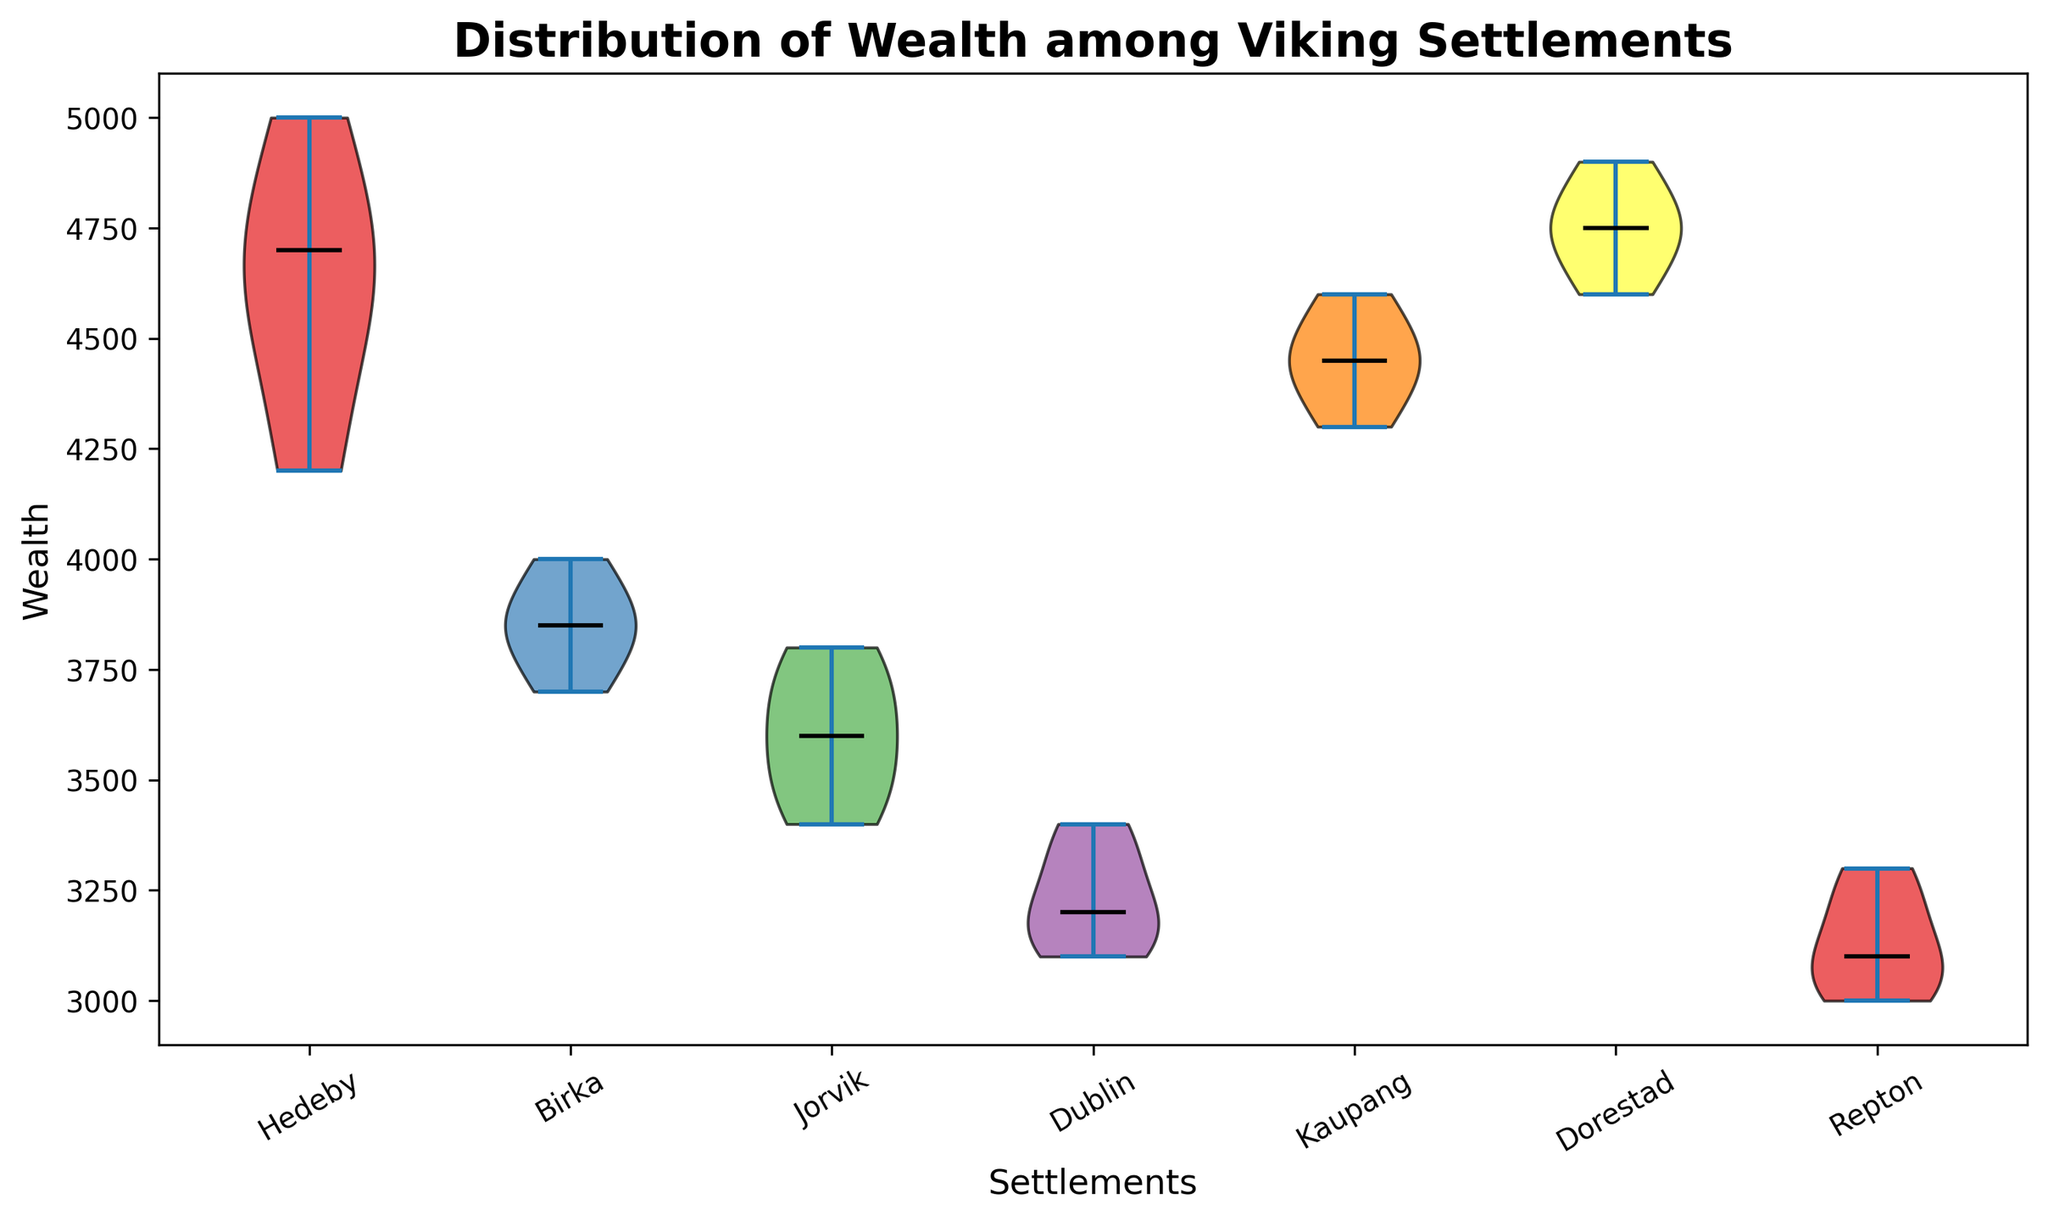What is the median wealth in Hedeby? Since it is a violin plot with medians indicated by a line, find the median line in Hedeby's distribution and read the value from the y-axis.
Answer: 4700 Which settlement has the widest distribution of wealth? Examine the width of the violins for each settlement. The widest one indicates the highest variance in wealth.
Answer: Hedeby Comparing the medians, which settlement is wealthier between Birka and Repton? Compare the heights of the median lines for Birka and Repton. The higher median line corresponds to the wealthier settlement.
Answer: Birka Which settlement has the lowest wealth as indicated by the plot? Look for the lowest point where the violin plot begins along the y-axis.
Answer: Repton What is the difference between the median wealth of Dorestad and Dublin? Identify the median values for both Dorestad and Dublin. Subtract Dublin's median from Dorestad's median: 4750 - 3200.
Answer: 1550 Which settlement's median wealth is closest to 4500? Check the median lines closest to 4500 and identify the corresponding settlement.
Answer: Kaupang Rank the settlements from highest to lowest median wealth. Compare the heights of the median lines for all settlements and order them accordingly.
Answer: Dorestad, Hedeby, Kaupang, Birka, Jorvik, Dublin, Repton What can you infer about the wealth distribution in Dublin compared to Kaupang from the shape of their plots? Dublin's violin plot is narrower and shorter compared to Kaupang, indicating lower wealth and less variation.
Answer: Lower and less varied wealth in Dublin Which settlement has a wealth distribution that spans both above and below 3500? Identify the settlements with violin plots that extend above and below the 3500 mark on the y-axis.
Answer: Jorvik and Repton What is the range of wealth in Hedeby? Find the minimum and maximum points of Hedeby's violin plot on the y-axis and calculate the difference: 5000 - 4200.
Answer: 800 